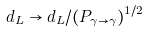Convert formula to latex. <formula><loc_0><loc_0><loc_500><loc_500>d _ { L } \to d _ { L } / ( P _ { \gamma \to \gamma } ) ^ { 1 / 2 }</formula> 